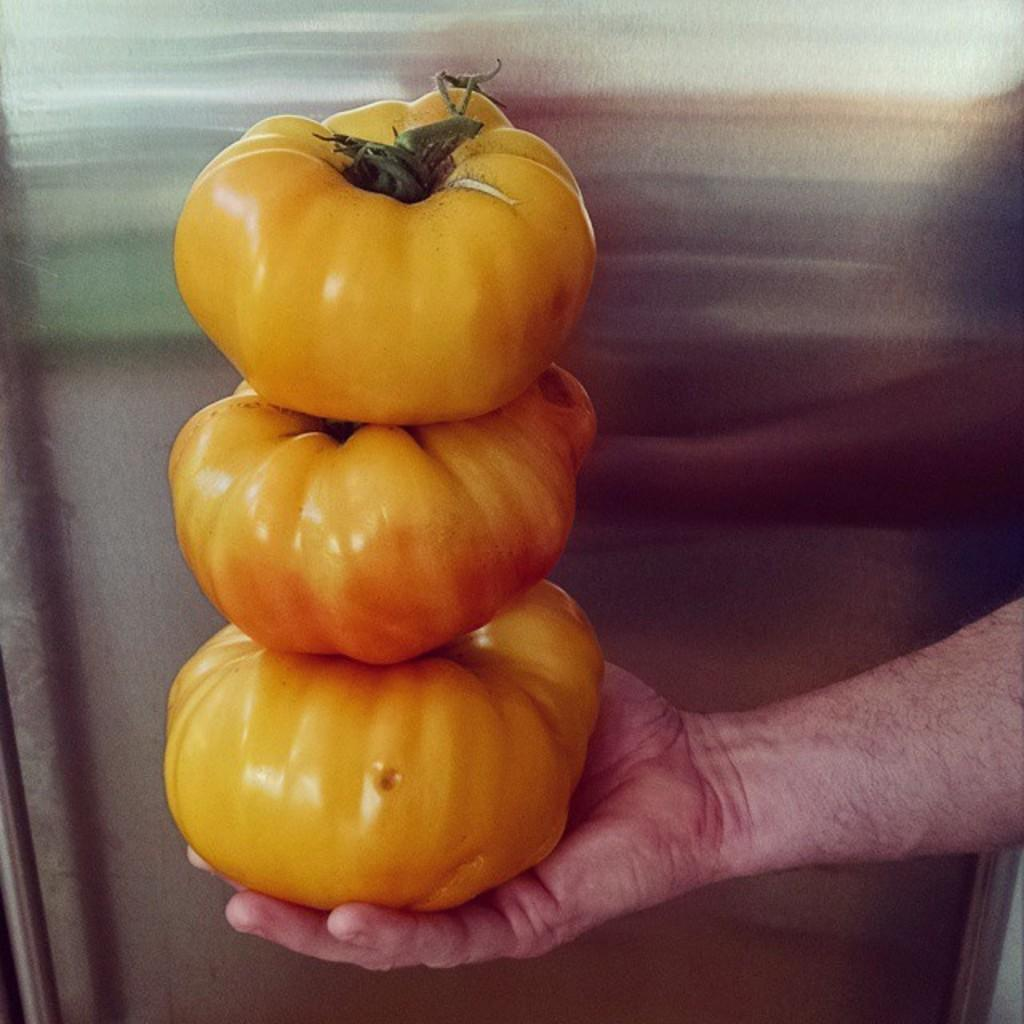What can be seen in the image? There is a person's hand in the image. What is the hand holding? The hand is holding yellow objects. What type of tent can be seen in the image? There is no tent present in the image; it only shows a person's hand holding yellow objects. 